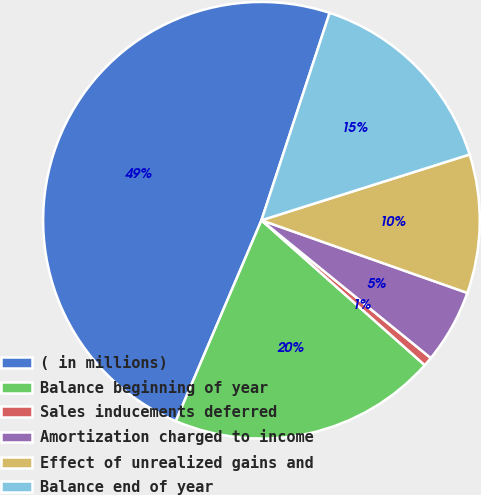<chart> <loc_0><loc_0><loc_500><loc_500><pie_chart><fcel>( in millions)<fcel>Balance beginning of year<fcel>Sales inducements deferred<fcel>Amortization charged to income<fcel>Effect of unrealized gains and<fcel>Balance end of year<nl><fcel>48.64%<fcel>19.86%<fcel>0.68%<fcel>5.47%<fcel>10.27%<fcel>15.07%<nl></chart> 